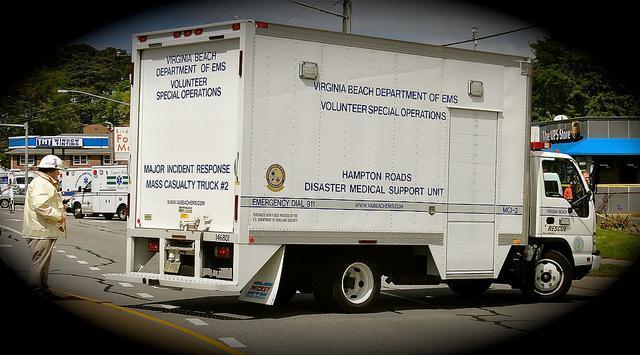How many wheels does the large truck have?
Give a very brief answer. 6. How many trucks are visible?
Give a very brief answer. 2. How many cars have zebra stripes?
Give a very brief answer. 0. 